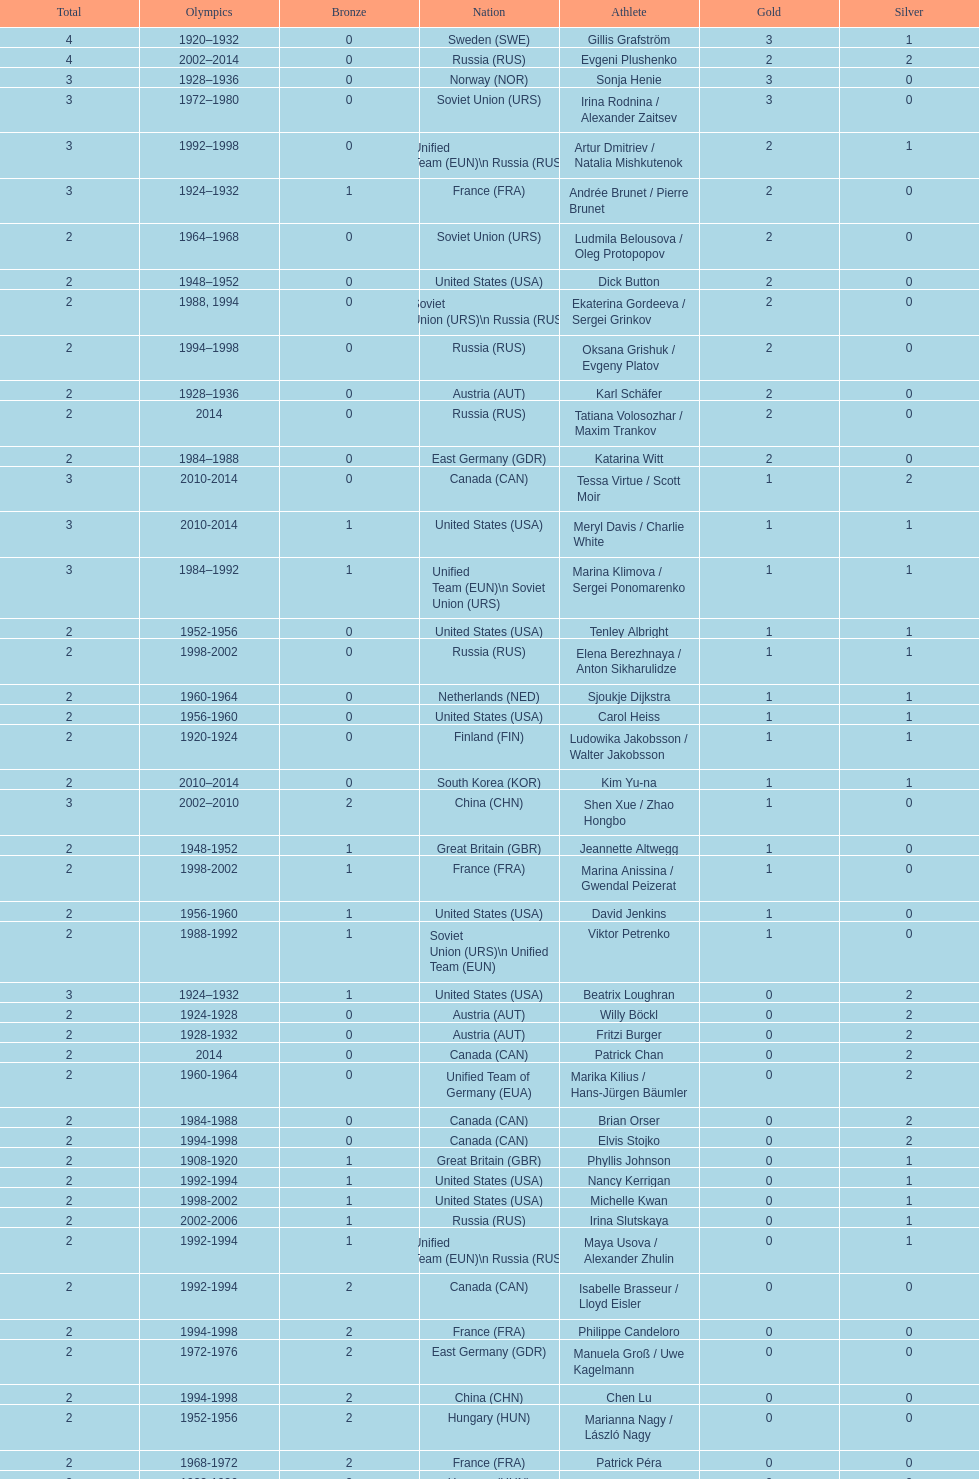Which nation was the first to win three gold medals for olympic figure skating? Sweden. 